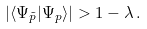<formula> <loc_0><loc_0><loc_500><loc_500>| \langle \Psi _ { \tilde { p } } | \Psi _ { p } \rangle | > 1 - \lambda \, .</formula> 